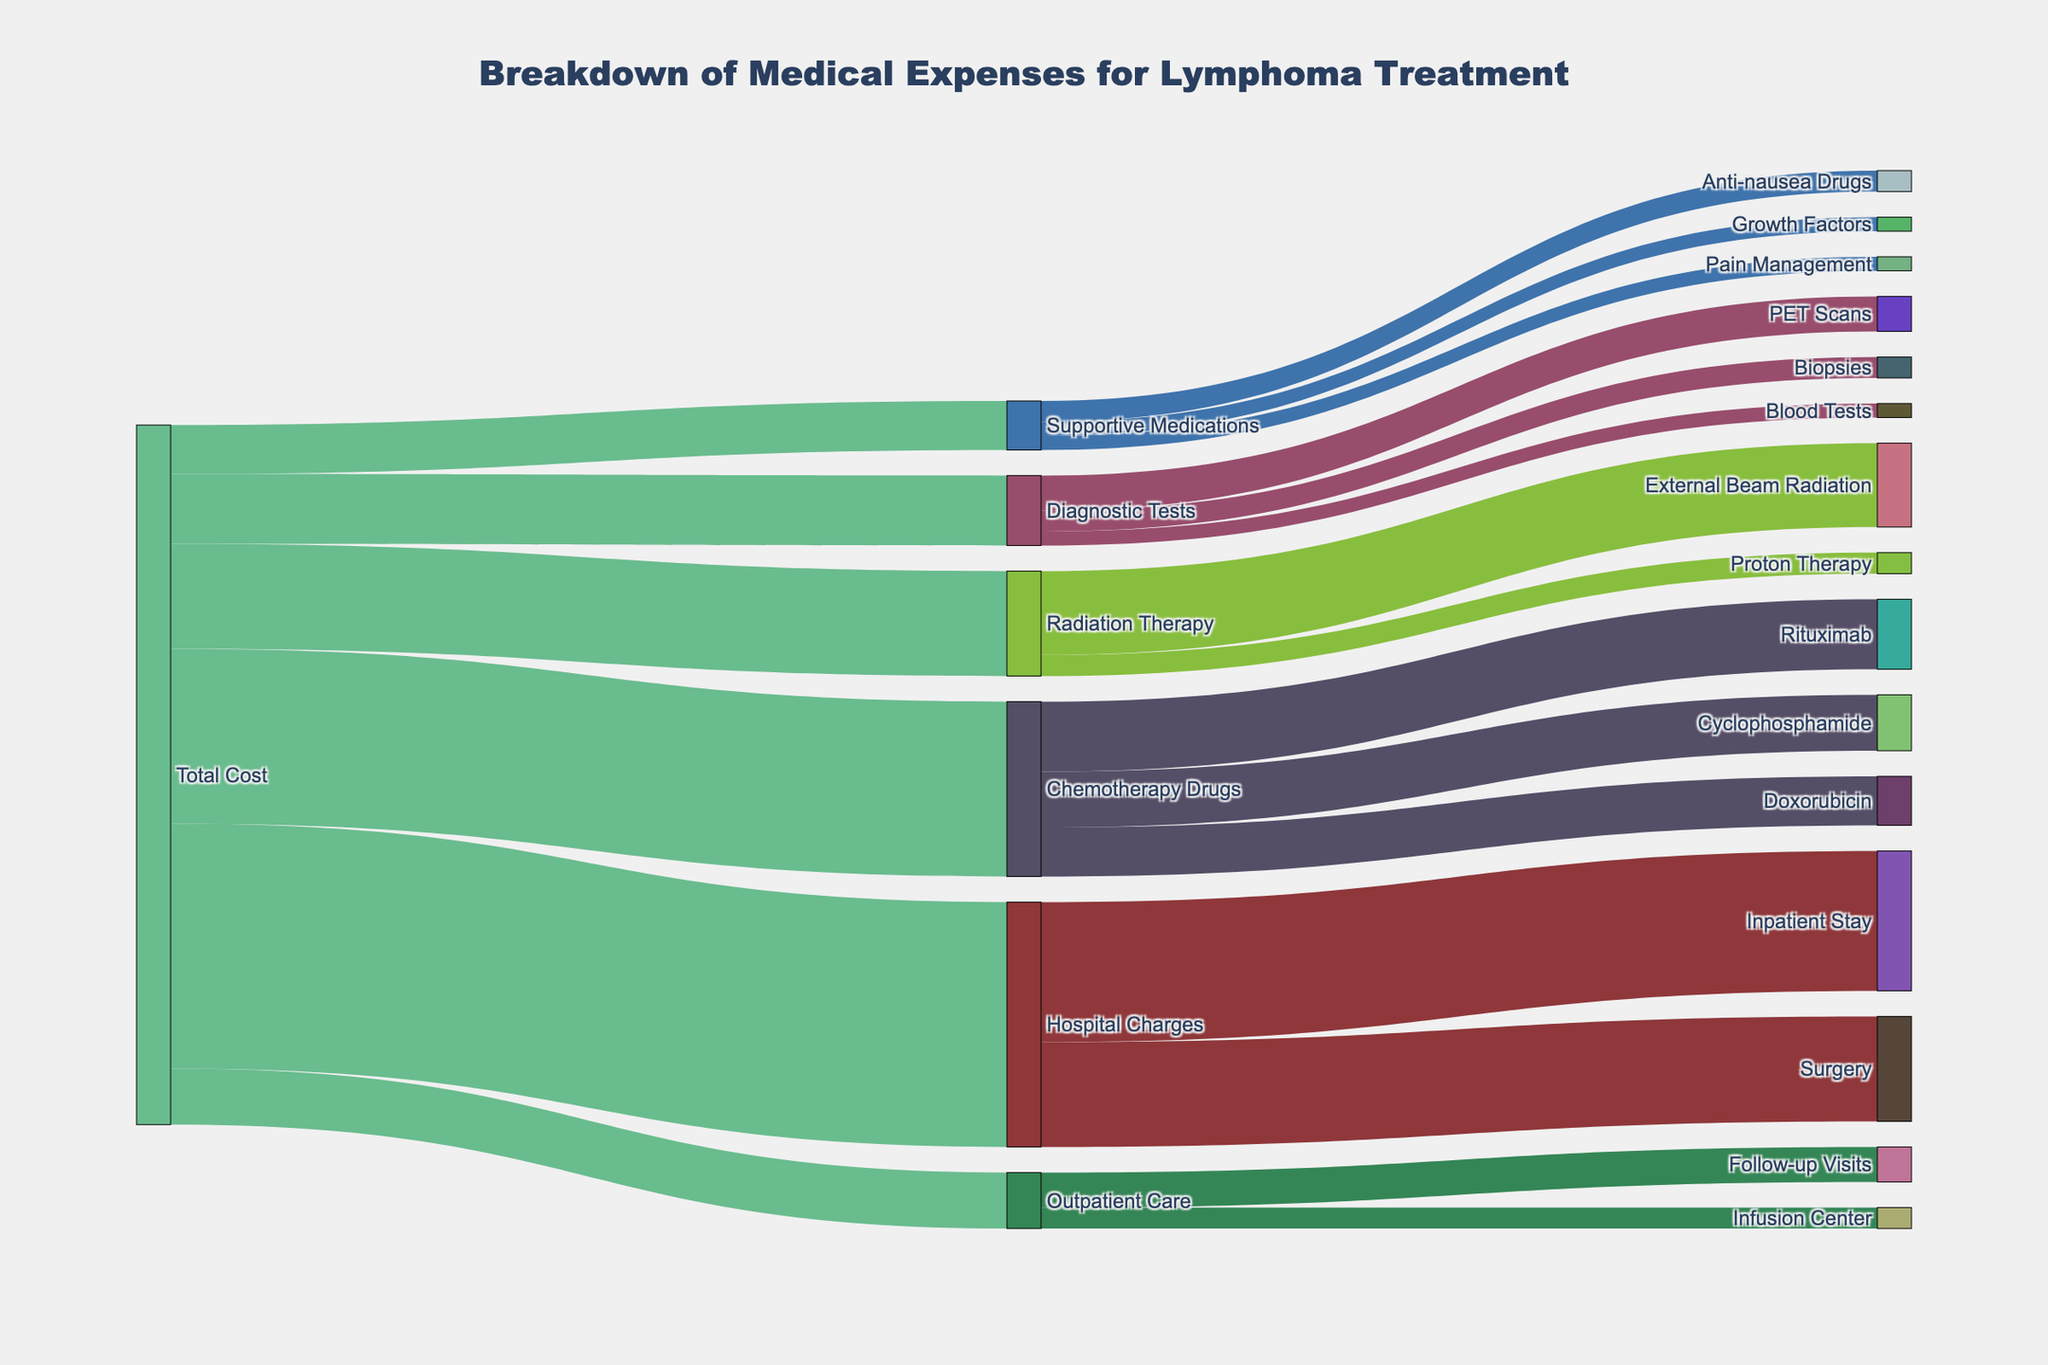What's the total cost of radiation therapy? From the diagram, radiation therapy breaks down into external beam radiation ($12,000) and proton therapy ($3,000). Adding these gives us $12,000 + $3,000 = $15,000.
Answer: $15,000 Which segment has the highest individual value? Looking at the thickness of the links, Hospital Charges for Inpatient Stay has the highest individual value which is $20,000.
Answer: Inpatient Stay How much is spent on supportive medications in total? Supportive medications break down into anti-nausea drugs ($3,000), pain management ($2,000), and growth factors ($2,000). Adding these gives us $3,000 + $2,000 + $2,000 = $7,000.
Answer: $7,000 What is the combined value of PET scans and biopsies? PET scans cost $5,000 and biopsies cost $3,000. Adding these gives us $5,000 + $3,000 = $8,000.
Answer: $8,000 How much more is spent on chemotherapy drugs compared to outpatient care? Chemotherapy drugs cost $25,000, and outpatient care costs $8,000. The difference is $25,000 - $8,000 = $17,000.
Answer: $17,000 How does the cost for supportive medications compare to that for diagnostic tests? Supportive medications cost $7,000, and diagnostic tests cost $10,000. The supportive medications' cost is $3,000 less than that for diagnostic tests.
Answer: $3,000 less Which category has the most subdivisions? Hospital Charges has two subdivisions: Inpatient Stay and Surgery. Chemotherapy Drugs also has three subdivisions: Rituximab, Cyclophosphamide, and Doxorubicin. Therefore, Chemotherapy Drugs and Supportive Medications have the most subdivisions, each with three.
Answer: Chemotherapy Drugs and Supportive Medications What percentage of the total cost is attributed to surgery? Surgery costs $15,000 out of the total $100,000. The percentage is ($15,000 / $100,000) * 100 = 15%.
Answer: 15% Which treatment method within radiation therapy is more costly? External Beam Radiation costs $12,000 compared to Proton Therapy at $3,000, making External Beam Radiation more costly.
Answer: External Beam Radiation 